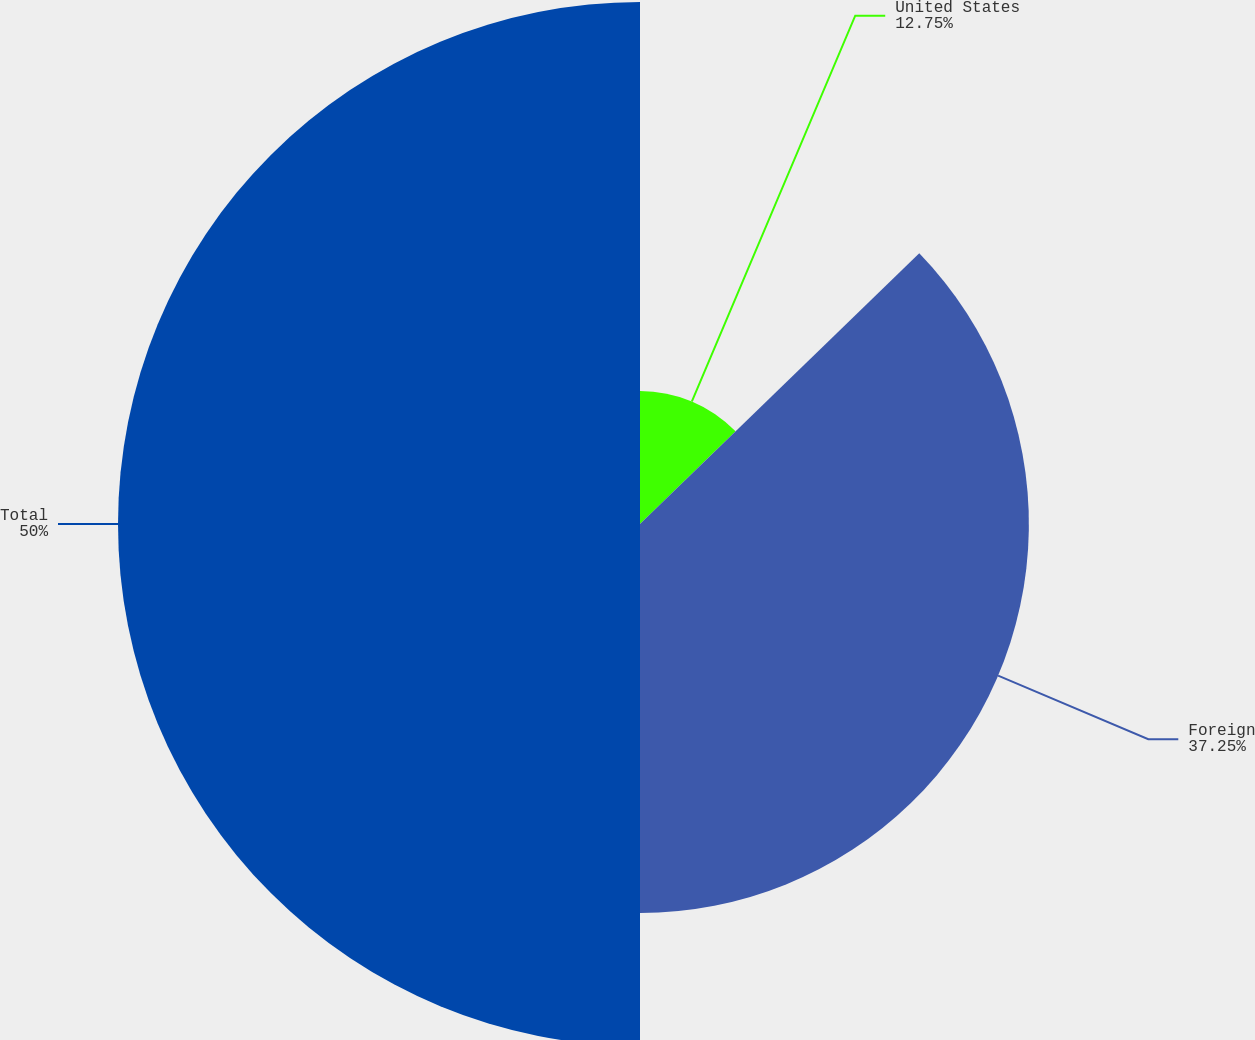Convert chart. <chart><loc_0><loc_0><loc_500><loc_500><pie_chart><fcel>United States<fcel>Foreign<fcel>Total<nl><fcel>12.75%<fcel>37.25%<fcel>50.0%<nl></chart> 